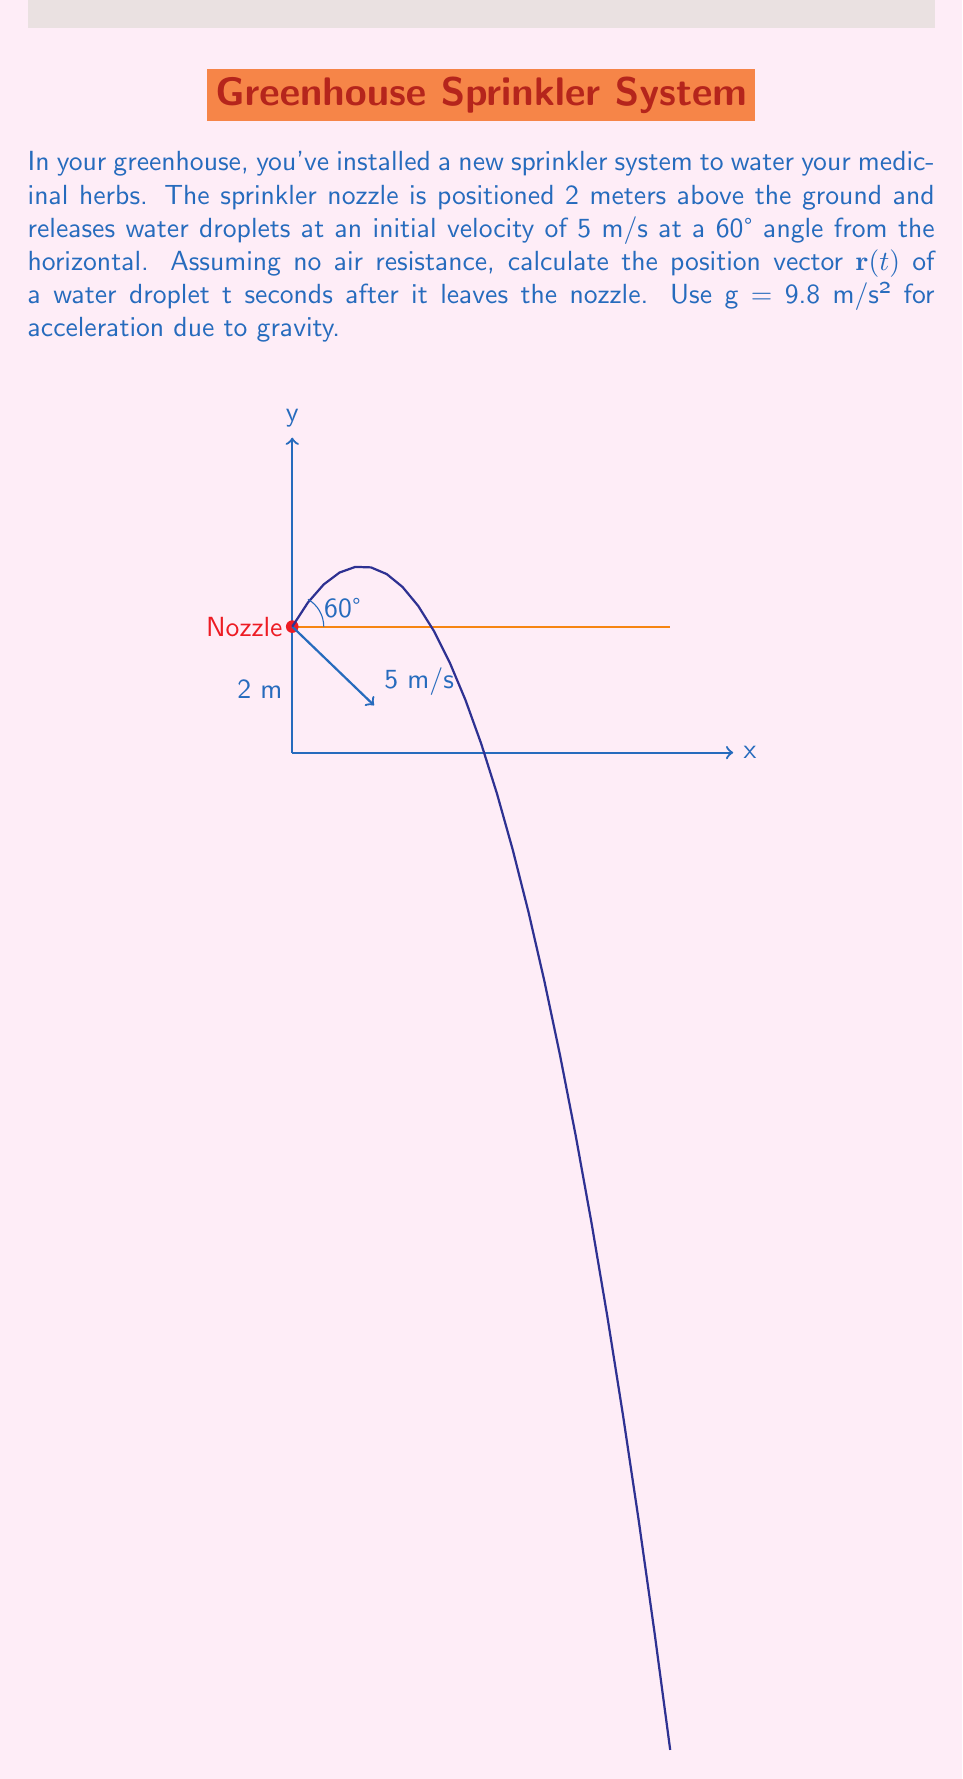Solve this math problem. Let's approach this step-by-step:

1) The position vector $\mathbf{r}(t)$ can be written as:

   $\mathbf{r}(t) = x(t)\hat{i} + y(t)\hat{j}$

2) For the x-component, there's no acceleration, so we use:
   
   $x(t) = x_0 + v_{0x}t$

   Where $x_0 = 0$ and $v_{0x} = v_0 \cos{\theta}$

3) For the y-component, we have constant acceleration due to gravity:
   
   $y(t) = y_0 + v_{0y}t - \frac{1}{2}gt^2$

   Where $y_0 = 2$ (initial height), $v_{0y} = v_0 \sin{\theta}$, and $g = 9.8$ m/s²

4) Now, let's substitute the values:
   
   $v_0 = 5$ m/s
   $\theta = 60° = \frac{\pi}{3}$ radians

5) Calculate $v_{0x}$ and $v_{0y}$:
   
   $v_{0x} = 5 \cos{\frac{\pi}{3}} = 2.5$ m/s
   $v_{0y} = 5 \sin{\frac{\pi}{3}} = 4.33$ m/s

6) Now we can write our position vector:

   $x(t) = 2.5t$
   $y(t) = 2 + 4.33t - 4.9t^2$

7) Combining these into vector form:

   $\mathbf{r}(t) = (2.5t)\hat{i} + (2 + 4.33t - 4.9t^2)\hat{j}$

This vector function gives the position of the water droplet at any time t after it leaves the nozzle.
Answer: $\mathbf{r}(t) = (2.5t)\hat{i} + (2 + 4.33t - 4.9t^2)\hat{j}$ 